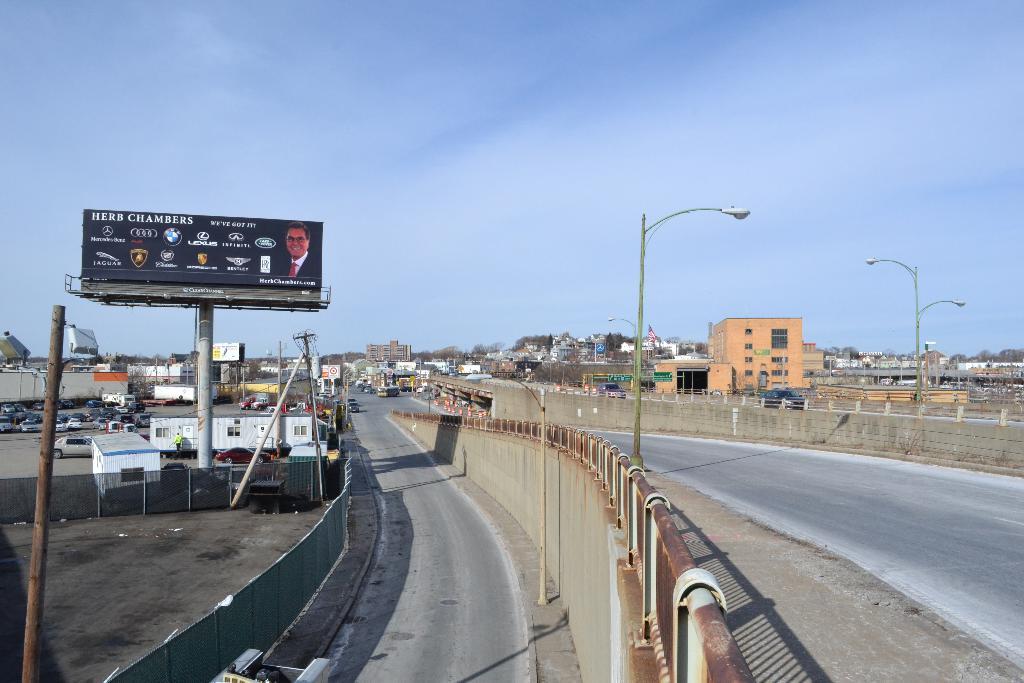What car company has a tiger as their logo on the billboard?
Your answer should be very brief. Jaguar. 